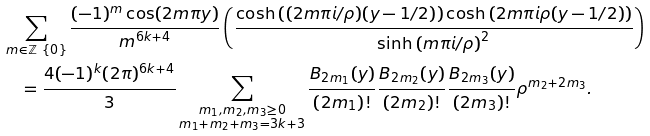Convert formula to latex. <formula><loc_0><loc_0><loc_500><loc_500>& \sum _ { m \in \mathbb { Z } \ \{ 0 \} } \frac { ( - 1 ) ^ { m } \cos ( 2 m \pi y ) } { m ^ { 6 k + 4 } } \left ( \frac { \cosh \left ( ( 2 m \pi i / \rho ) ( y - 1 / 2 ) \right ) \cosh \left ( 2 m \pi i \rho ( y - 1 / 2 ) \right ) } { \sinh \left ( m \pi i / \rho \right ) ^ { 2 } } \right ) \\ & \quad = \frac { 4 ( - 1 ) ^ { k } ( 2 \pi ) ^ { 6 k + 4 } } { 3 } \sum _ { \substack { m _ { 1 } , m _ { 2 } , m _ { 3 } \geq 0 \\ m _ { 1 } + m _ { 2 } + m _ { 3 } = 3 k + 3 } } \frac { B _ { 2 m _ { 1 } } ( y ) } { ( 2 m _ { 1 } ) ! } \frac { B _ { 2 m _ { 2 } } ( y ) } { ( 2 m _ { 2 } ) ! } \frac { B _ { 2 m _ { 3 } } ( y ) } { ( 2 m _ { 3 } ) ! } \rho ^ { m _ { 2 } + 2 m _ { 3 } } .</formula> 